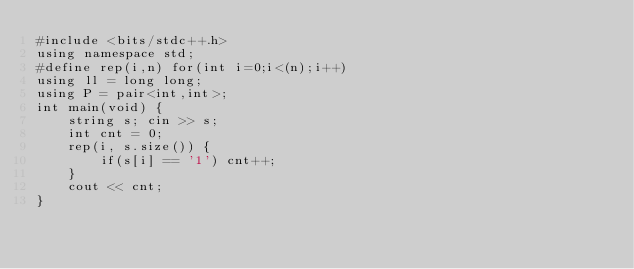<code> <loc_0><loc_0><loc_500><loc_500><_C++_>#include <bits/stdc++.h>
using namespace std;
#define rep(i,n) for(int i=0;i<(n);i++)
using ll = long long;
using P = pair<int,int>;
int main(void) {
    string s; cin >> s;
    int cnt = 0;
    rep(i, s.size()) {
        if(s[i] == '1') cnt++;
    }
    cout << cnt;
}
</code> 